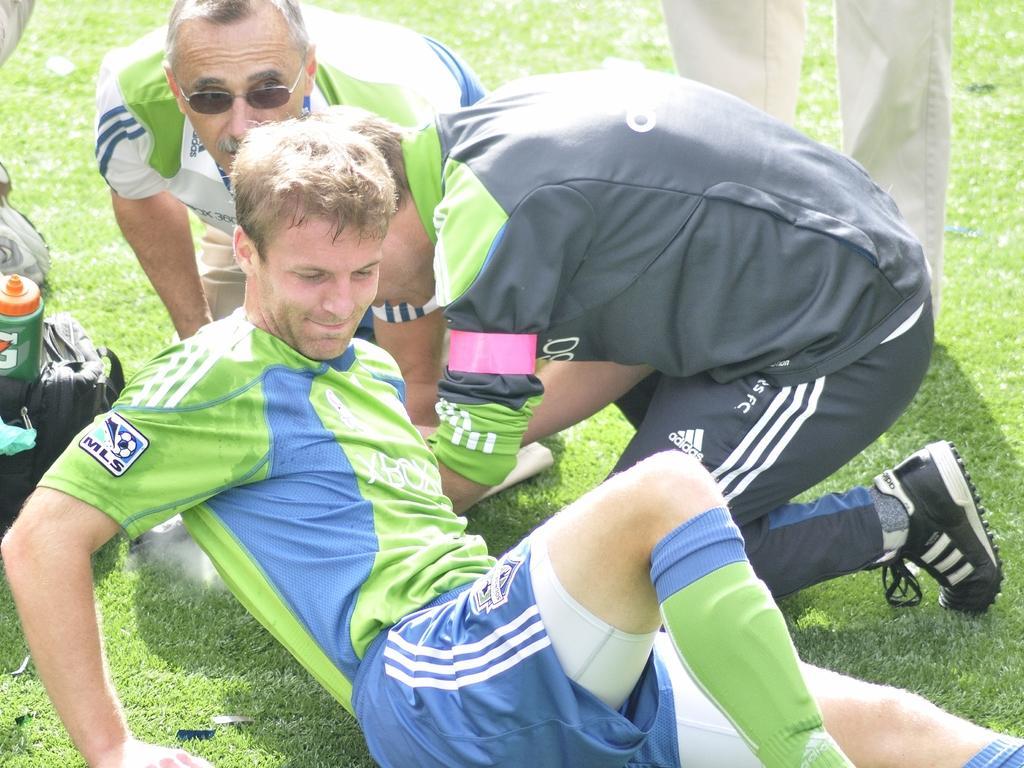Describe this image in one or two sentences. In this image I can see few persons are sitting and few are standing. And beside them there is a bag, On the bag there is a bottle. In the background there is a grass. 